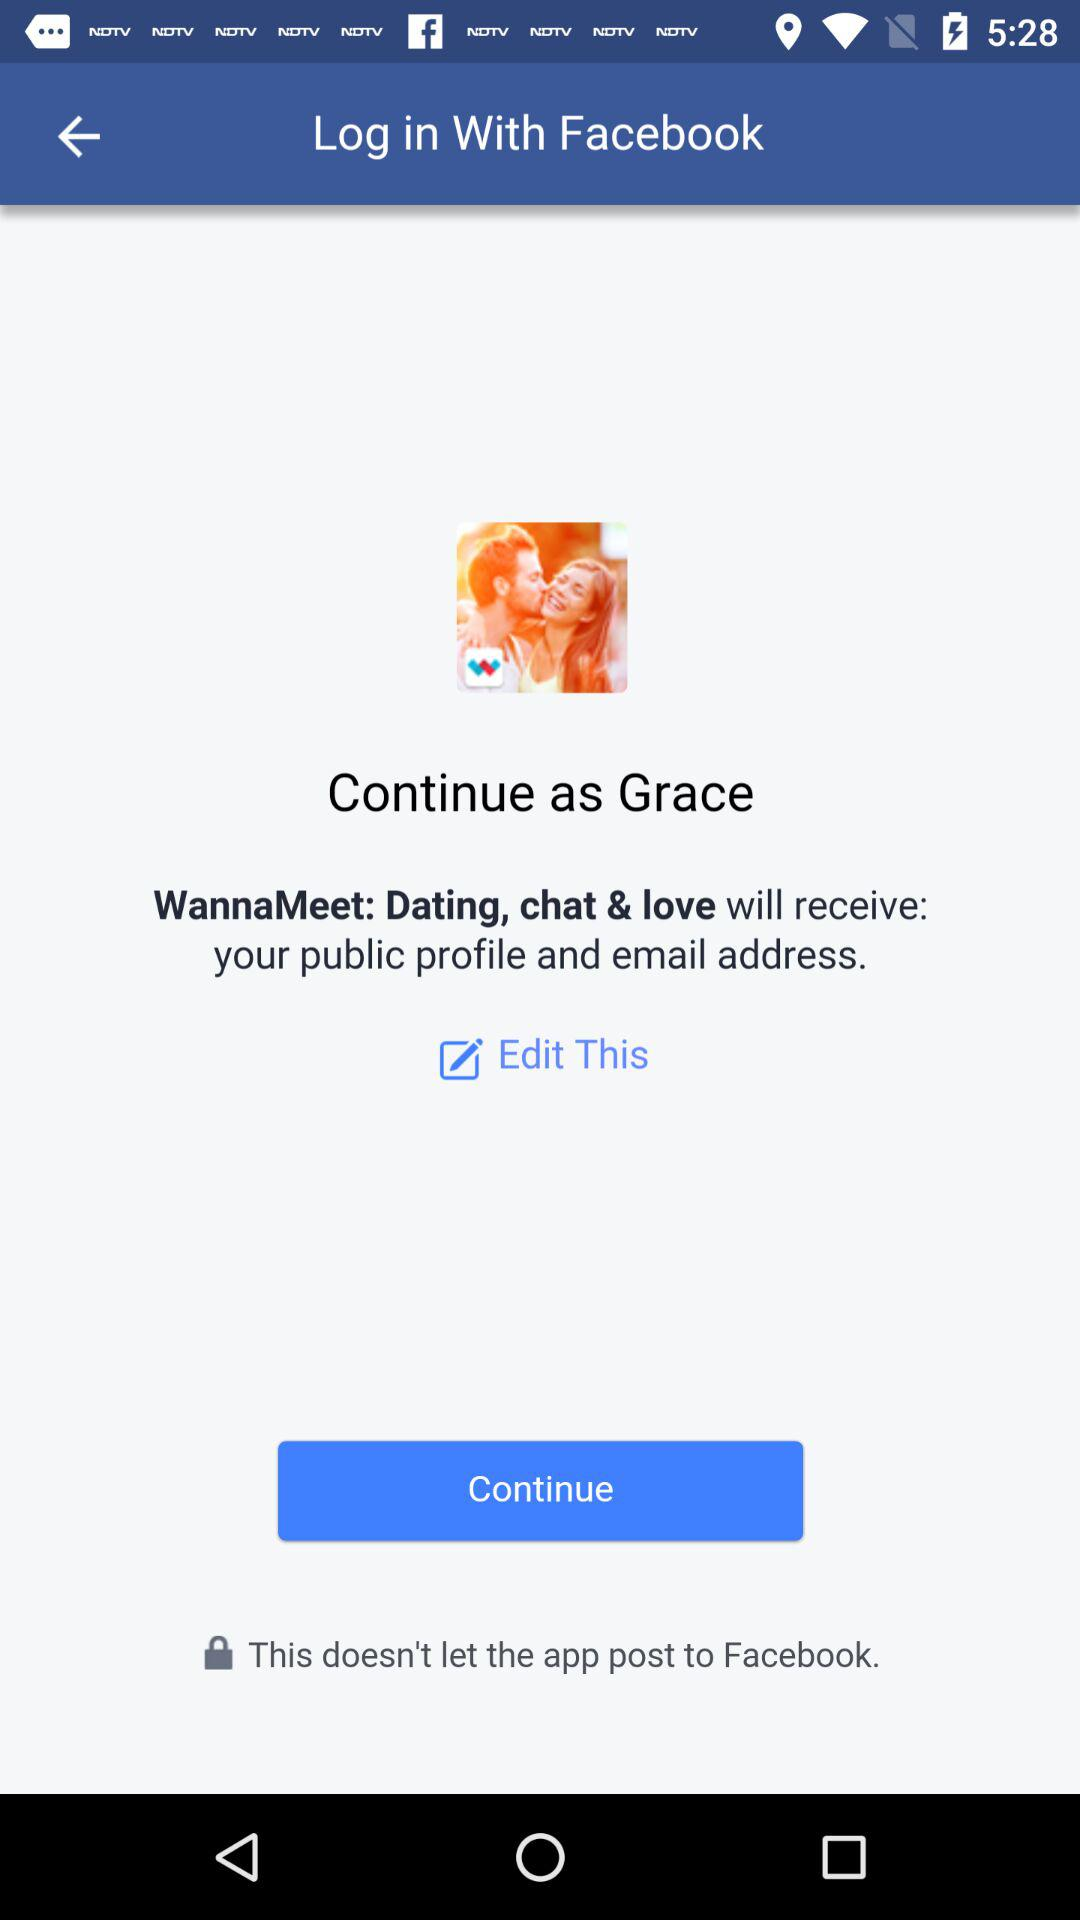What is the name of the user? The name of the user is Grace. 